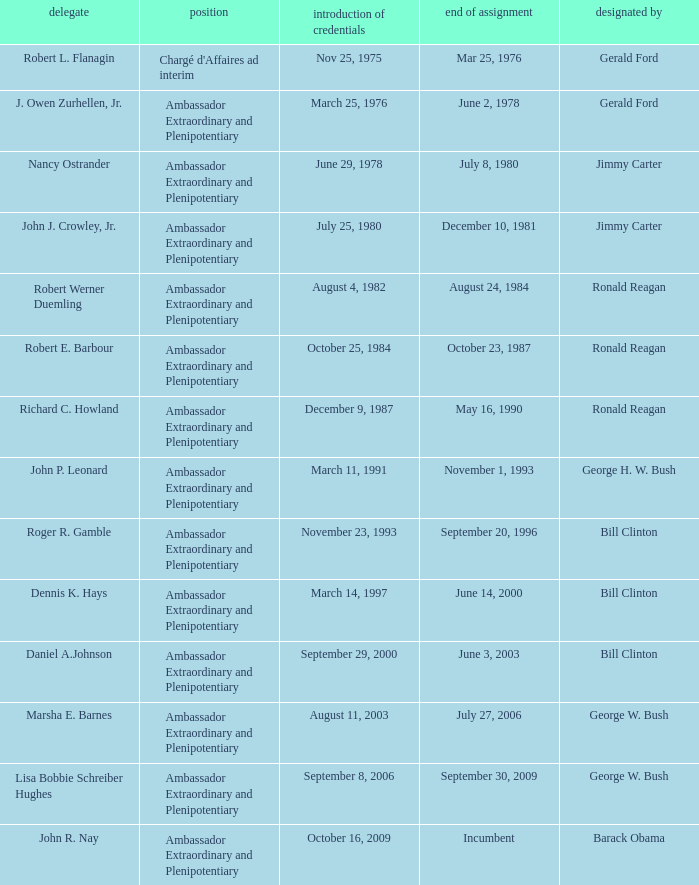Help me parse the entirety of this table. {'header': ['delegate', 'position', 'introduction of credentials', 'end of assignment', 'designated by'], 'rows': [['Robert L. Flanagin', "Chargé d'Affaires ad interim", 'Nov 25, 1975', 'Mar 25, 1976', 'Gerald Ford'], ['J. Owen Zurhellen, Jr.', 'Ambassador Extraordinary and Plenipotentiary', 'March 25, 1976', 'June 2, 1978', 'Gerald Ford'], ['Nancy Ostrander', 'Ambassador Extraordinary and Plenipotentiary', 'June 29, 1978', 'July 8, 1980', 'Jimmy Carter'], ['John J. Crowley, Jr.', 'Ambassador Extraordinary and Plenipotentiary', 'July 25, 1980', 'December 10, 1981', 'Jimmy Carter'], ['Robert Werner Duemling', 'Ambassador Extraordinary and Plenipotentiary', 'August 4, 1982', 'August 24, 1984', 'Ronald Reagan'], ['Robert E. Barbour', 'Ambassador Extraordinary and Plenipotentiary', 'October 25, 1984', 'October 23, 1987', 'Ronald Reagan'], ['Richard C. Howland', 'Ambassador Extraordinary and Plenipotentiary', 'December 9, 1987', 'May 16, 1990', 'Ronald Reagan'], ['John P. Leonard', 'Ambassador Extraordinary and Plenipotentiary', 'March 11, 1991', 'November 1, 1993', 'George H. W. Bush'], ['Roger R. Gamble', 'Ambassador Extraordinary and Plenipotentiary', 'November 23, 1993', 'September 20, 1996', 'Bill Clinton'], ['Dennis K. Hays', 'Ambassador Extraordinary and Plenipotentiary', 'March 14, 1997', 'June 14, 2000', 'Bill Clinton'], ['Daniel A.Johnson', 'Ambassador Extraordinary and Plenipotentiary', 'September 29, 2000', 'June 3, 2003', 'Bill Clinton'], ['Marsha E. Barnes', 'Ambassador Extraordinary and Plenipotentiary', 'August 11, 2003', 'July 27, 2006', 'George W. Bush'], ['Lisa Bobbie Schreiber Hughes', 'Ambassador Extraordinary and Plenipotentiary', 'September 8, 2006', 'September 30, 2009', 'George W. Bush'], ['John R. Nay', 'Ambassador Extraordinary and Plenipotentiary', 'October 16, 2009', 'Incumbent', 'Barack Obama']]} Which representative was the Ambassador Extraordinary and Plenipotentiary and had a Termination of Mission date September 20, 1996? Roger R. Gamble. 